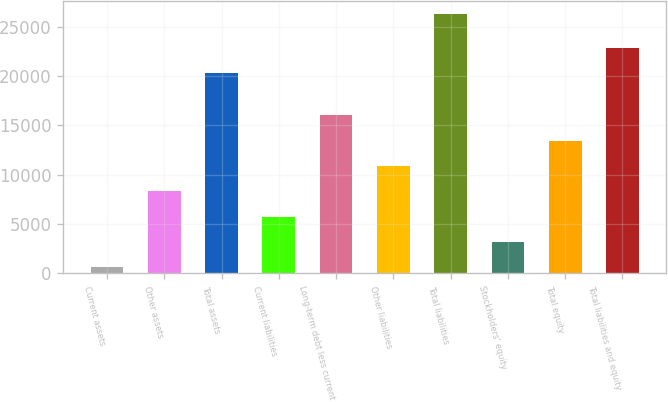Convert chart to OTSL. <chart><loc_0><loc_0><loc_500><loc_500><bar_chart><fcel>Current assets<fcel>Other assets<fcel>Total assets<fcel>Current liabilities<fcel>Long-term debt less current<fcel>Other liabilities<fcel>Total liabilities<fcel>Stockholders' equity<fcel>Total equity<fcel>Total liabilities and equity<nl><fcel>585<fcel>8298.6<fcel>20284<fcel>5727.4<fcel>16012.2<fcel>10869.8<fcel>26297<fcel>3156.2<fcel>13441<fcel>22855.2<nl></chart> 